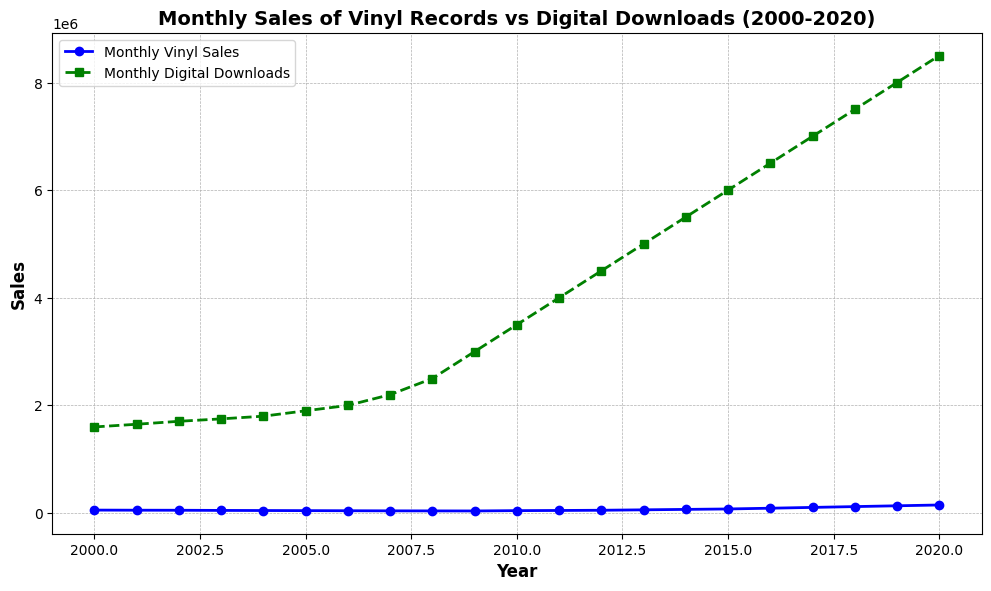what is the average monthly sales of vinyl records in 2010 and 2011? For 2010 and 2011, the sales are 45000 and 48000 respectively. The average can be calculated as (45000 + 48000) / 2.
Answer: 46500 Which year had the highest monthly sales of vinyl records? By observing the curve representing vinyl sales, the peak point occurs at the rightmost side of the chart in 2020.
Answer: 2020 In what year do monthly digital downloads surpass 5,000,000? The curve representing digital downloads surpasses the 5,000,000 mark between the 2012 and 2013 data points.
Answer: 2013 How does the trend in vinyl records sales compare to digital downloads from 2000 to 2020? Vinyl record sales initially decline and then rise sharply from around 2010 onwards, while digital downloads continuously increase throughout the period.
Answer: Vinyl sales decline then rise, downloads continuously increase What is the difference in monthly digital downloads between 2000 and 2020? Monthly digital downloads in 2000 are 1,600,000, and in 2020 are 8,500,000. Subtracting these gives 8,500,000 - 1,600,000.
Answer: 6,900,000 Which year had the slowest growth in monthly vinyl record sales compared to the preceding year? Comparing each year's sales visually, the smallest increase in vinyl sales occurs between 2001 and 2002, where it decreases rather slightly.
Answer: 2002 Between which consecutive years do we see the largest increase in monthly digital downloads? The curve for digital downloads has the steepest rise between 2008 (2,500,000) and 2009 (3,000,000), indicating the largest yearly increase.
Answer: 2008-2009 What is the approximate monthly sales figure for vinyl records in the year 2017? The plotted data point for 2017 on the vinyl sales curve appears to be around 105,000 units.
Answer: 105,000 By how much did monthly vinyl sales increase from 2015 to 2020? Vinyl sales in 2015 are 76,000 units, and 2020 is 150,000 units. The increase is 150,000 - 76,000.
Answer: 74,000 Can you identify a year when both vinyl records and digital downloads increased compared to the previous year? Both curves trend upwards in 2011, showcasing increases in both categories.
Answer: 2011 